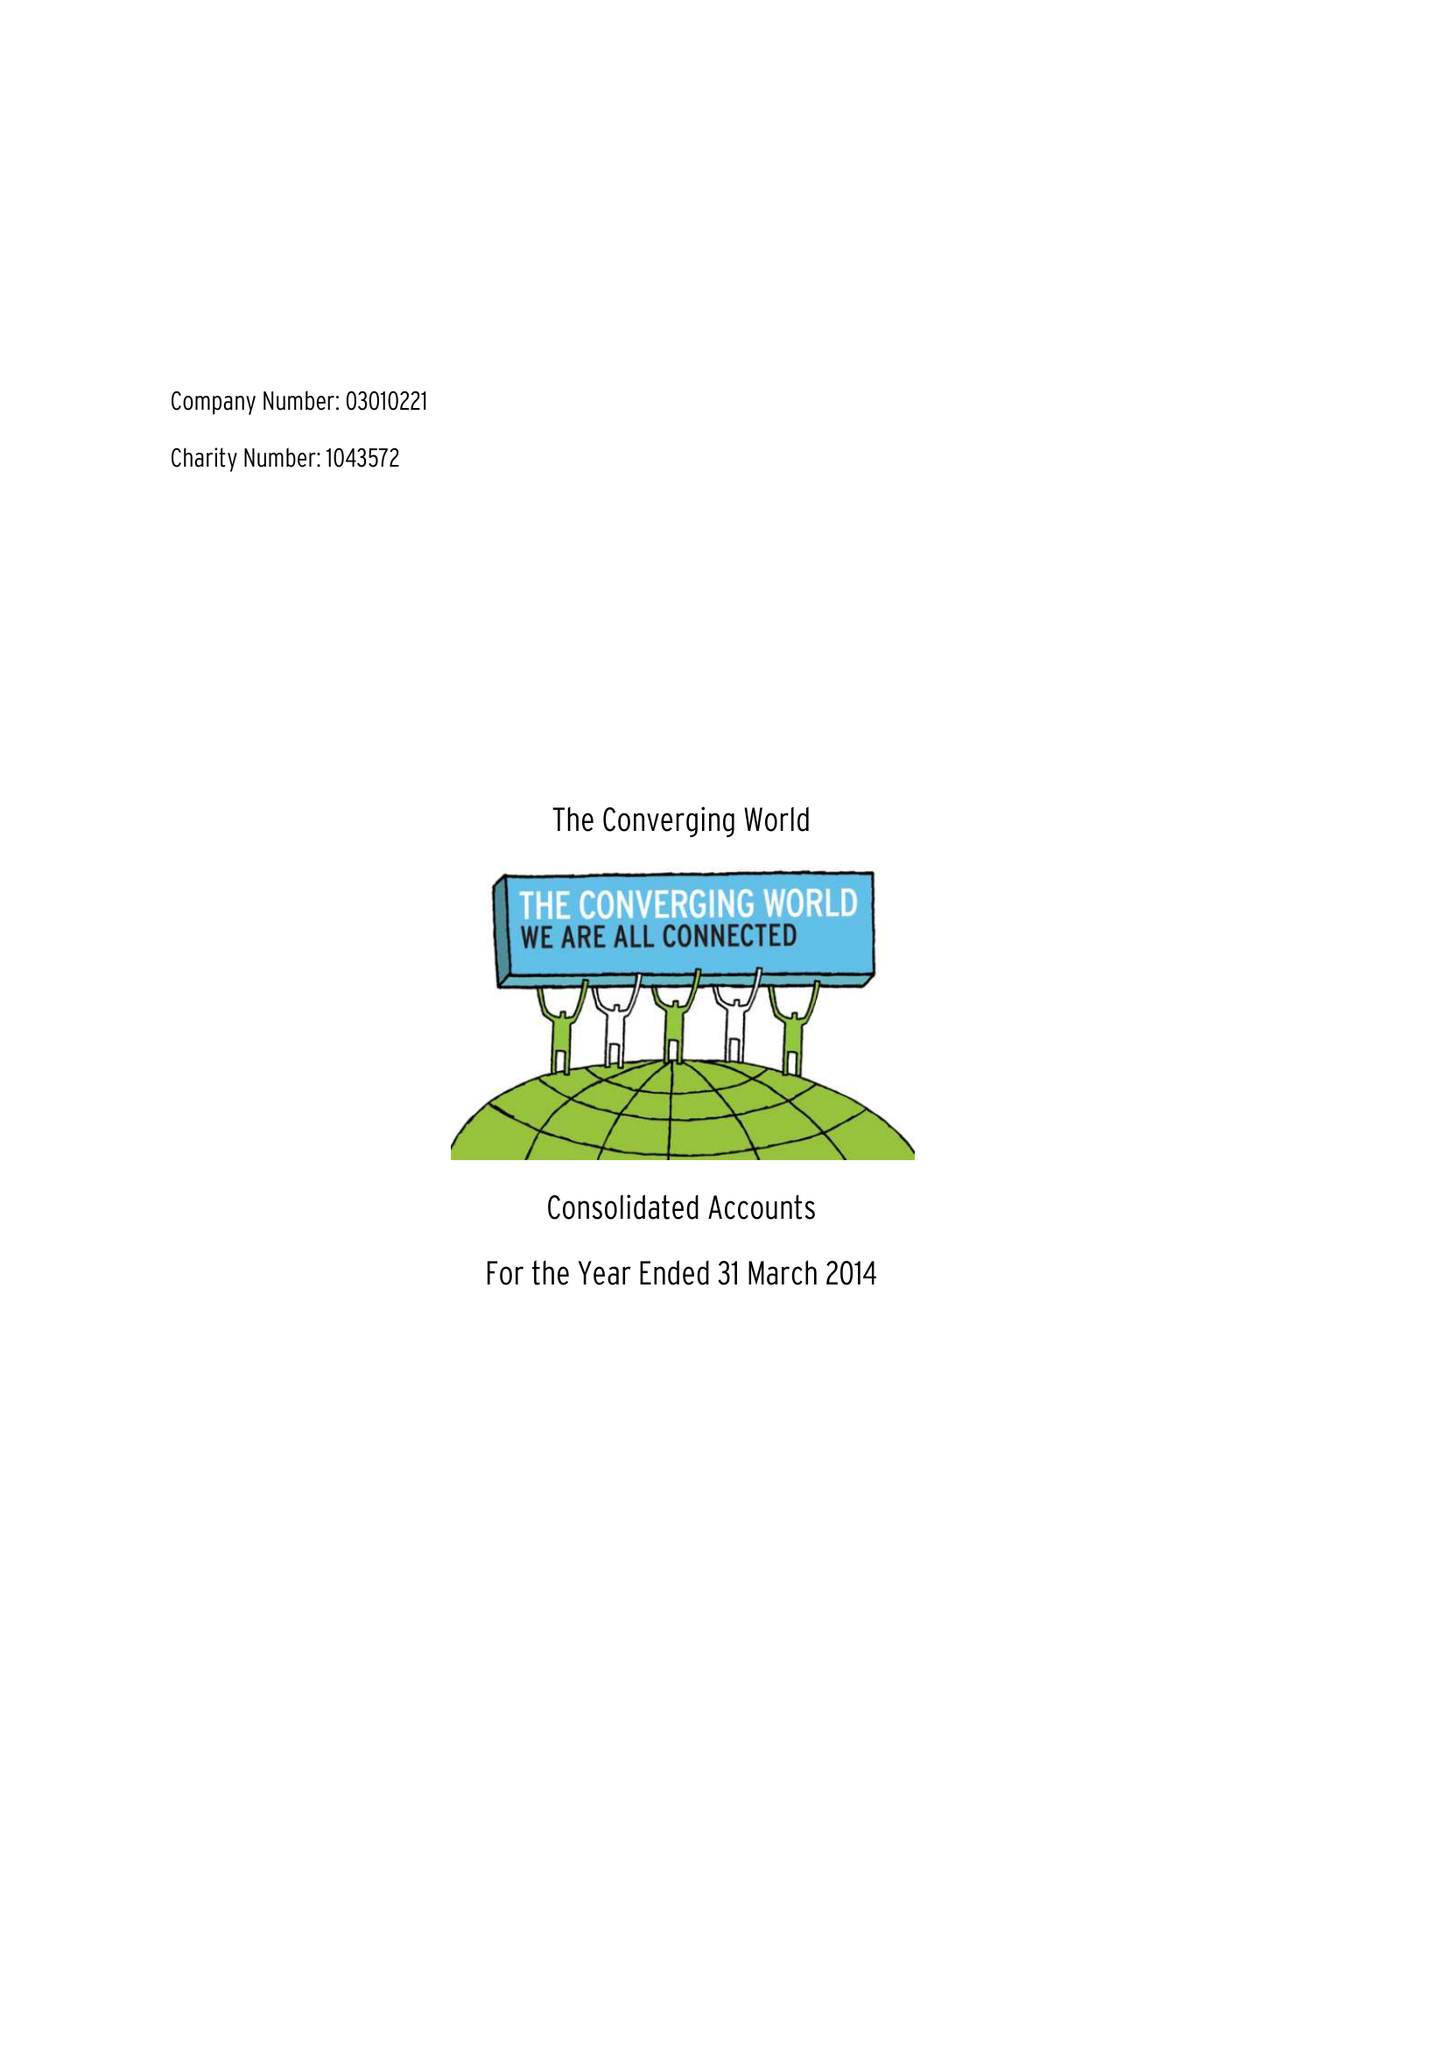What is the value for the charity_number?
Answer the question using a single word or phrase. 1043572 